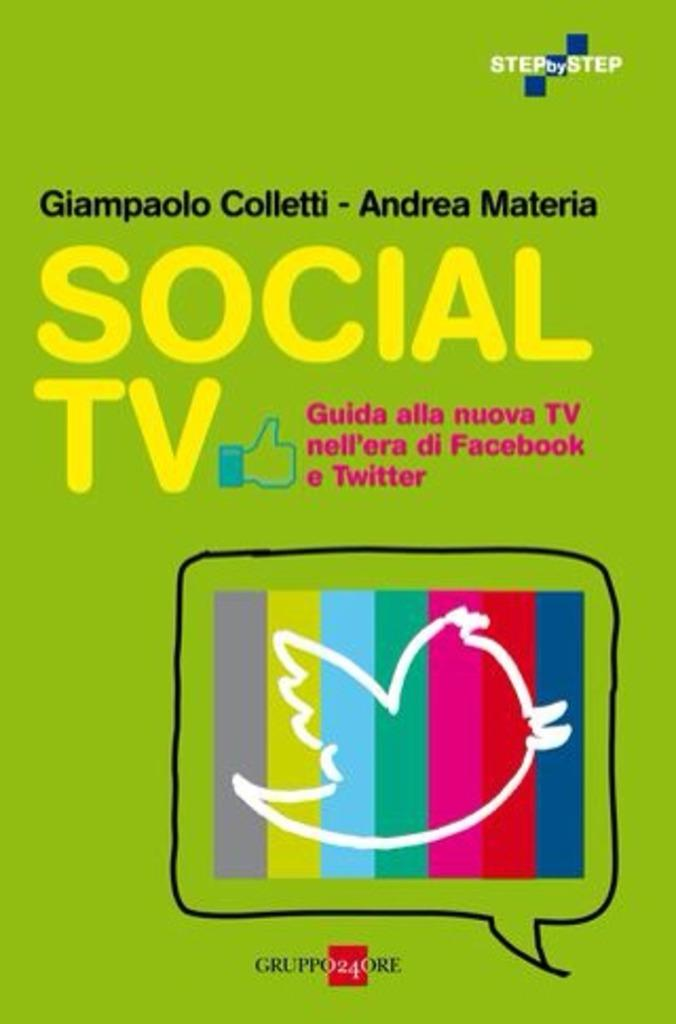<image>
Create a compact narrative representing the image presented. a cartoon tv that says social tv on it 